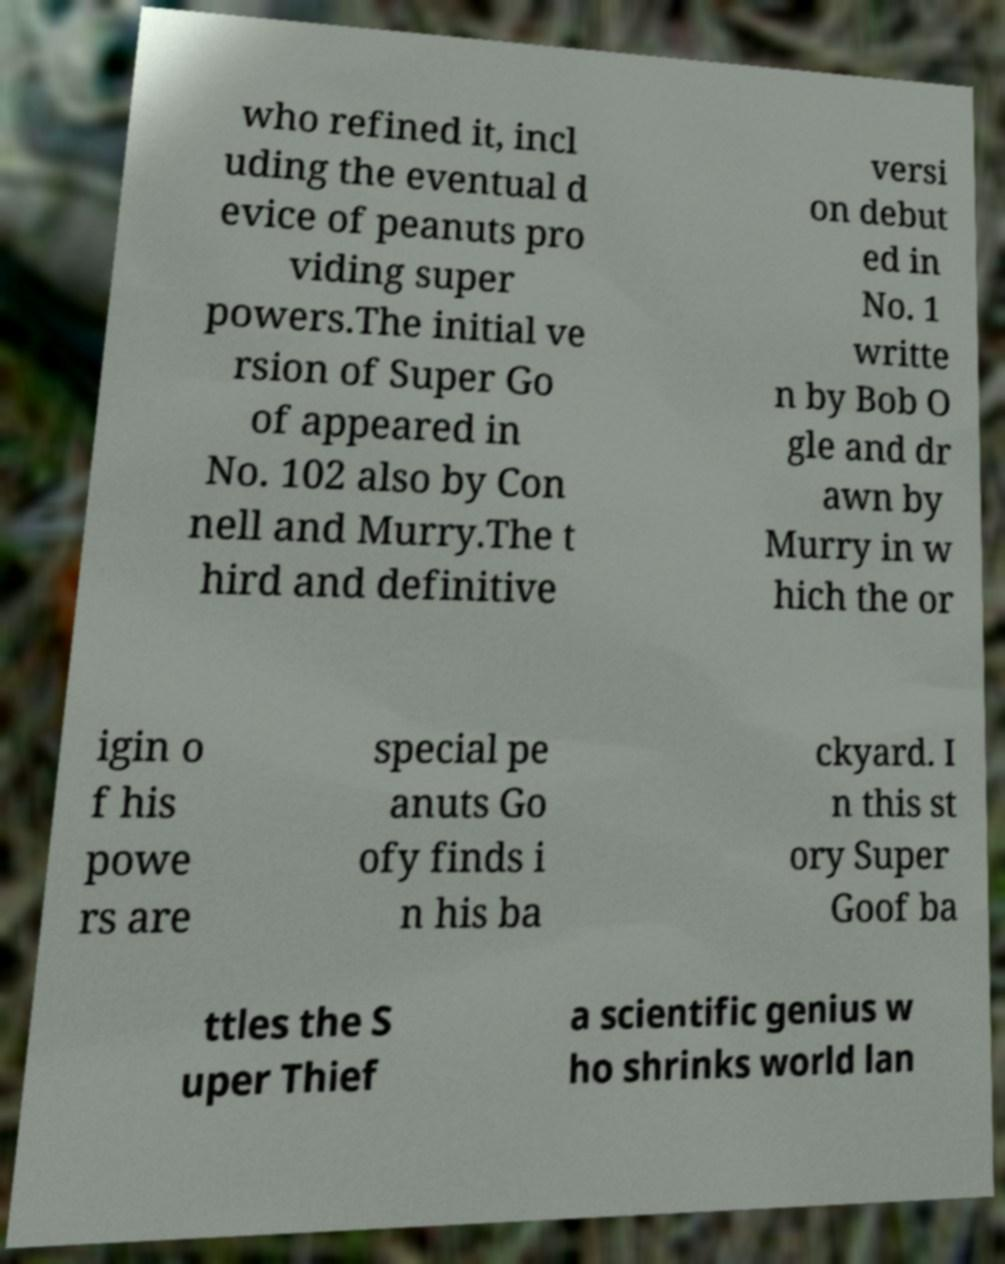Could you extract and type out the text from this image? who refined it, incl uding the eventual d evice of peanuts pro viding super powers.The initial ve rsion of Super Go of appeared in No. 102 also by Con nell and Murry.The t hird and definitive versi on debut ed in No. 1 writte n by Bob O gle and dr awn by Murry in w hich the or igin o f his powe rs are special pe anuts Go ofy finds i n his ba ckyard. I n this st ory Super Goof ba ttles the S uper Thief a scientific genius w ho shrinks world lan 